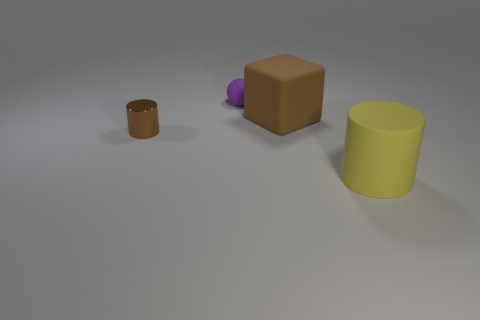Add 2 small objects. How many objects exist? 6 Subtract 1 blocks. How many blocks are left? 0 Subtract all yellow blocks. Subtract all yellow cylinders. How many blocks are left? 1 Subtract all purple balls. How many green cylinders are left? 0 Subtract all large brown objects. Subtract all small gray shiny objects. How many objects are left? 3 Add 4 big yellow rubber cylinders. How many big yellow rubber cylinders are left? 5 Add 3 brown matte spheres. How many brown matte spheres exist? 3 Subtract 0 purple blocks. How many objects are left? 4 Subtract all balls. How many objects are left? 3 